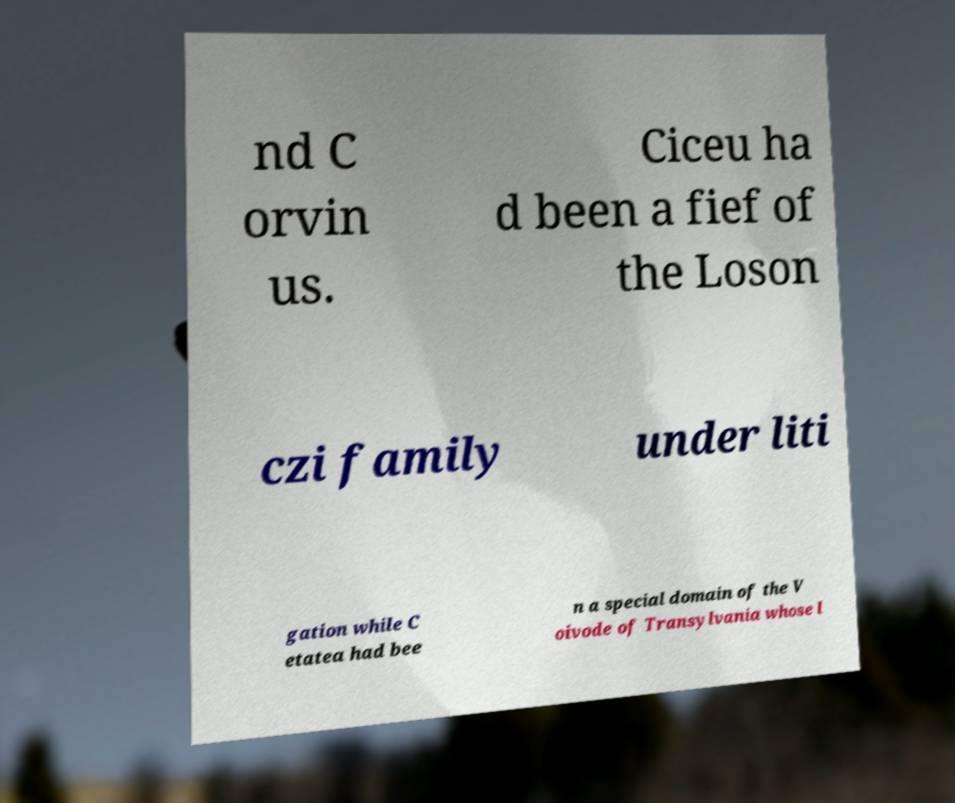There's text embedded in this image that I need extracted. Can you transcribe it verbatim? nd C orvin us. Ciceu ha d been a fief of the Loson czi family under liti gation while C etatea had bee n a special domain of the V oivode of Transylvania whose l 